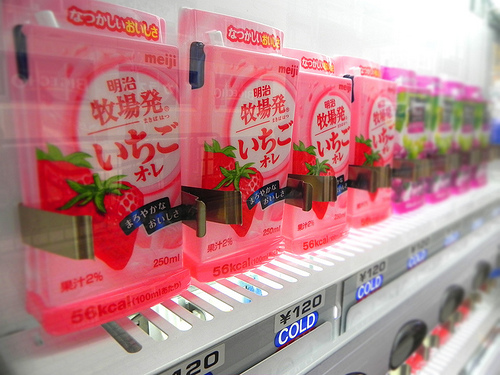<image>
Can you confirm if the pack is next to the pack? Yes. The pack is positioned adjacent to the pack, located nearby in the same general area. Is the strawberry thing above the price label? Yes. The strawberry thing is positioned above the price label in the vertical space, higher up in the scene. 